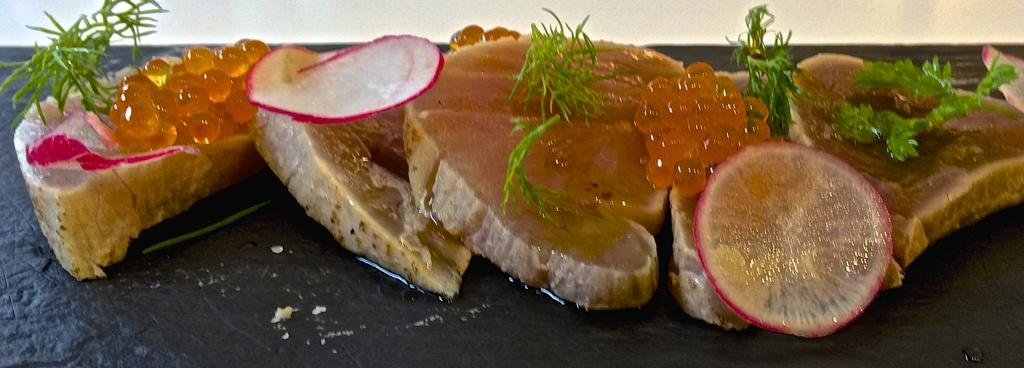What is the main subject of the image? The main subject of the image is food. What can be observed about the surface on which the food is placed? The surface is black. What type of soap is being used to clean the food in the image? There is no soap present in the image, as it features food on a black surface. What type of poison is visible in the image? There is no poison present in the image; it only contains food on a black surface. 